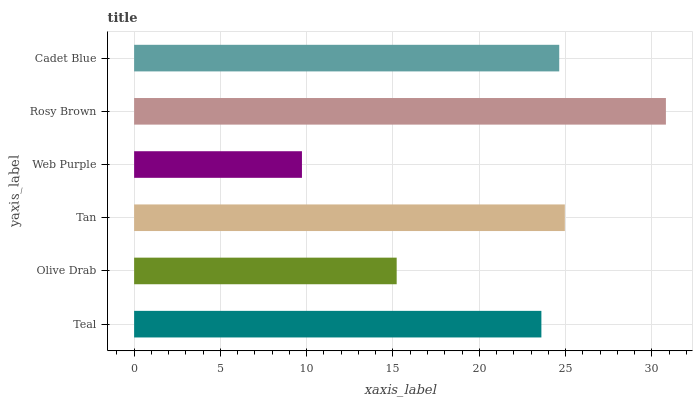Is Web Purple the minimum?
Answer yes or no. Yes. Is Rosy Brown the maximum?
Answer yes or no. Yes. Is Olive Drab the minimum?
Answer yes or no. No. Is Olive Drab the maximum?
Answer yes or no. No. Is Teal greater than Olive Drab?
Answer yes or no. Yes. Is Olive Drab less than Teal?
Answer yes or no. Yes. Is Olive Drab greater than Teal?
Answer yes or no. No. Is Teal less than Olive Drab?
Answer yes or no. No. Is Cadet Blue the high median?
Answer yes or no. Yes. Is Teal the low median?
Answer yes or no. Yes. Is Web Purple the high median?
Answer yes or no. No. Is Rosy Brown the low median?
Answer yes or no. No. 